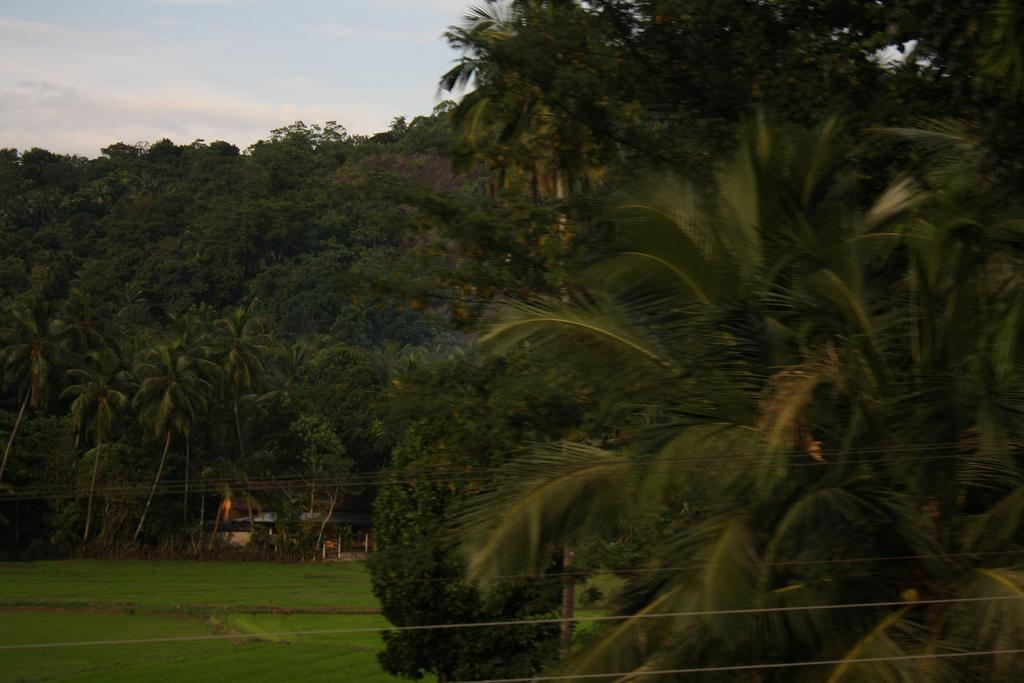What type of vegetation can be seen in the image? There are trees in the image. What structure is located at the bottom of the image? There appears to be a house at the bottom of the image. What type of ground cover is visible in the image? Grass is visible on the ground. How would you describe the sky in the image? The sky is blue and cloudy. Can you tell me how many sponges are used for cooking in the image? There are no sponges or cooking activities present in the image. What type of self-portrait is depicted in the image? There is no self-portrait present in the image; it features trees, a house, grass, and a blue, cloudy sky. 